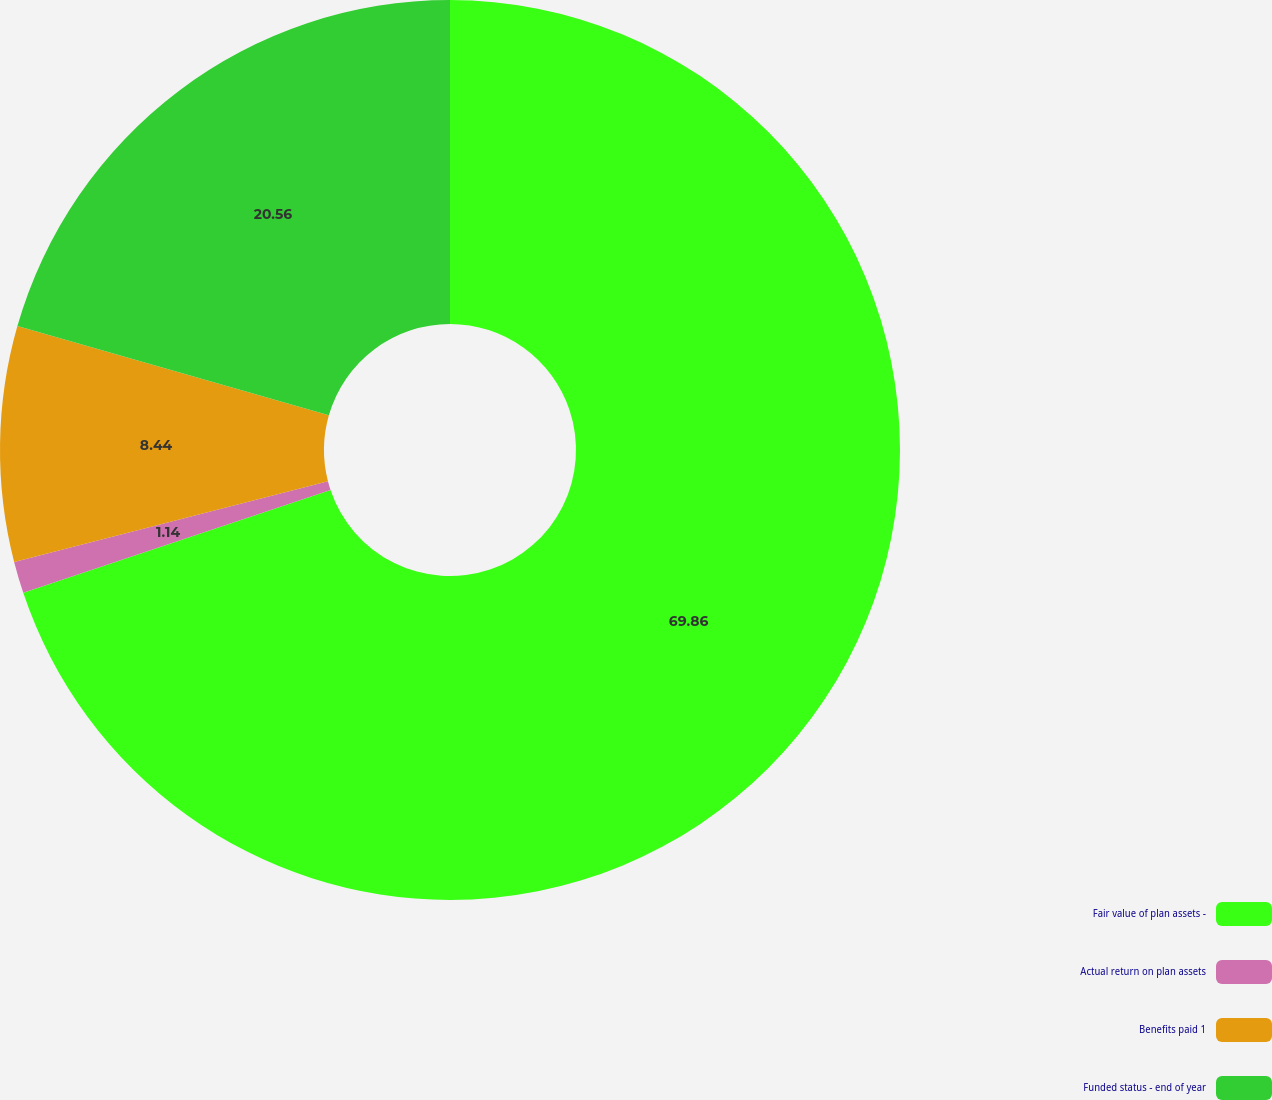Convert chart to OTSL. <chart><loc_0><loc_0><loc_500><loc_500><pie_chart><fcel>Fair value of plan assets -<fcel>Actual return on plan assets<fcel>Benefits paid 1<fcel>Funded status - end of year<nl><fcel>69.86%<fcel>1.14%<fcel>8.44%<fcel>20.56%<nl></chart> 